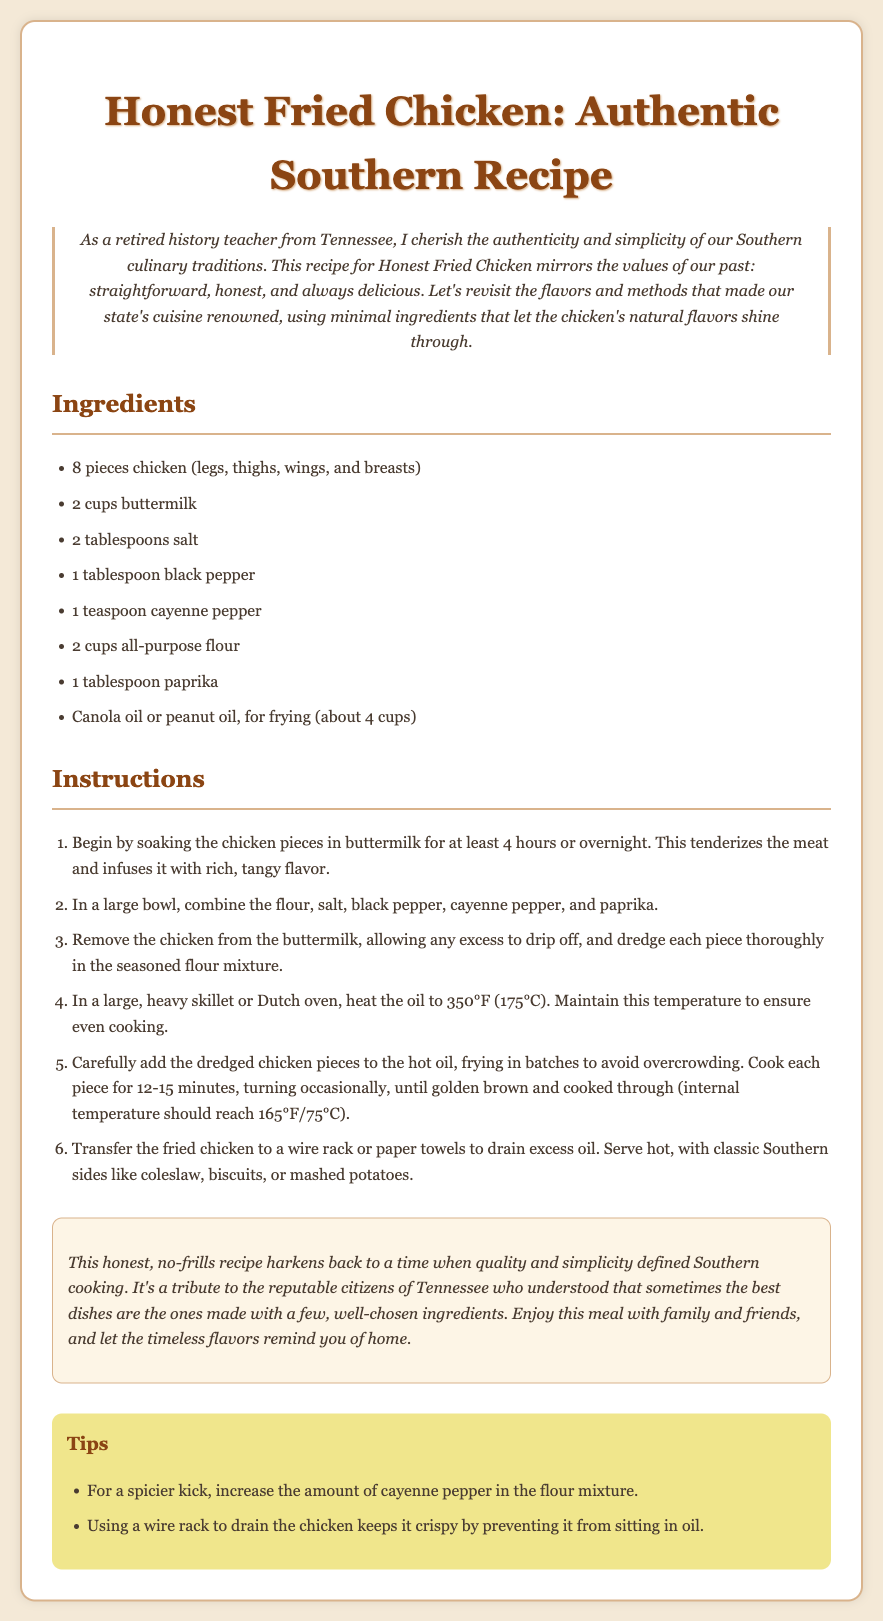what are the main ingredients? The main ingredients include chicken, buttermilk, salt, black pepper, cayenne pepper, flour, paprika, and oil.
Answer: chicken, buttermilk, salt, black pepper, cayenne pepper, flour, paprika, oil how long should the chicken soak in buttermilk? The instruction states that the chicken should soak in buttermilk for at least 4 hours or overnight.
Answer: 4 hours what is the frying temperature? The recipe specifies maintaining the oil temperature at 350°F.
Answer: 350°F how long does it take to cook each piece of chicken? The document states that each piece should be cooked for 12-15 minutes.
Answer: 12-15 minutes what is the internal temperature for cooked chicken? The internal temperature for cooked chicken should reach 165°F.
Answer: 165°F what can you serve with fried chicken? The recipe mentions serving the chicken with classic Southern sides such as coleslaw, biscuits, or mashed potatoes.
Answer: coleslaw, biscuits, mashed potatoes what is a tip for keeping chicken crispy? The recipe suggests using a wire rack to drain the chicken to keep it crispy.
Answer: wire rack what does the nostalgic note remind us of? The nostalgic note is a tribute to reputable citizens of Tennessee and the simplicity of quality dishes.
Answer: reputable citizens of Tennessee 